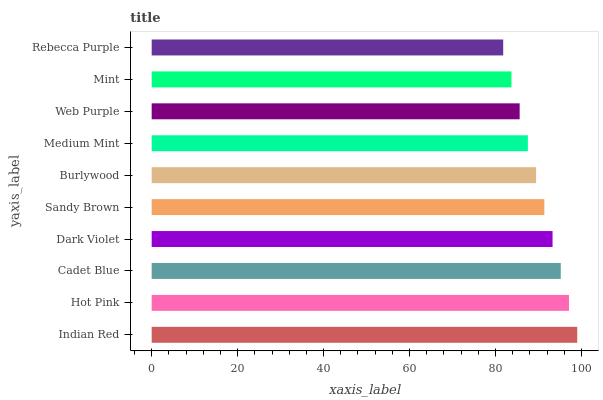Is Rebecca Purple the minimum?
Answer yes or no. Yes. Is Indian Red the maximum?
Answer yes or no. Yes. Is Hot Pink the minimum?
Answer yes or no. No. Is Hot Pink the maximum?
Answer yes or no. No. Is Indian Red greater than Hot Pink?
Answer yes or no. Yes. Is Hot Pink less than Indian Red?
Answer yes or no. Yes. Is Hot Pink greater than Indian Red?
Answer yes or no. No. Is Indian Red less than Hot Pink?
Answer yes or no. No. Is Sandy Brown the high median?
Answer yes or no. Yes. Is Burlywood the low median?
Answer yes or no. Yes. Is Rebecca Purple the high median?
Answer yes or no. No. Is Web Purple the low median?
Answer yes or no. No. 